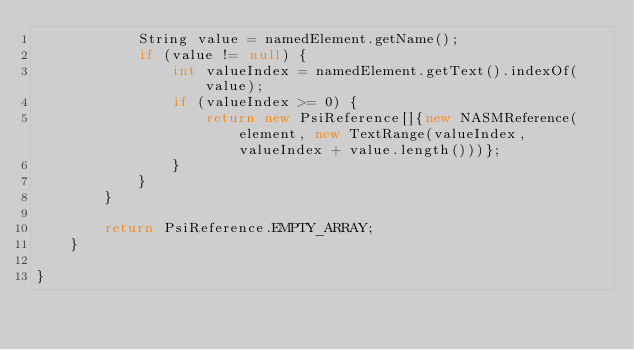<code> <loc_0><loc_0><loc_500><loc_500><_Java_>            String value = namedElement.getName();
            if (value != null) {
                int valueIndex = namedElement.getText().indexOf(value);
                if (valueIndex >= 0) {
                    return new PsiReference[]{new NASMReference(element, new TextRange(valueIndex, valueIndex + value.length()))};
                }
            }
        }

        return PsiReference.EMPTY_ARRAY;
    }

}
</code> 